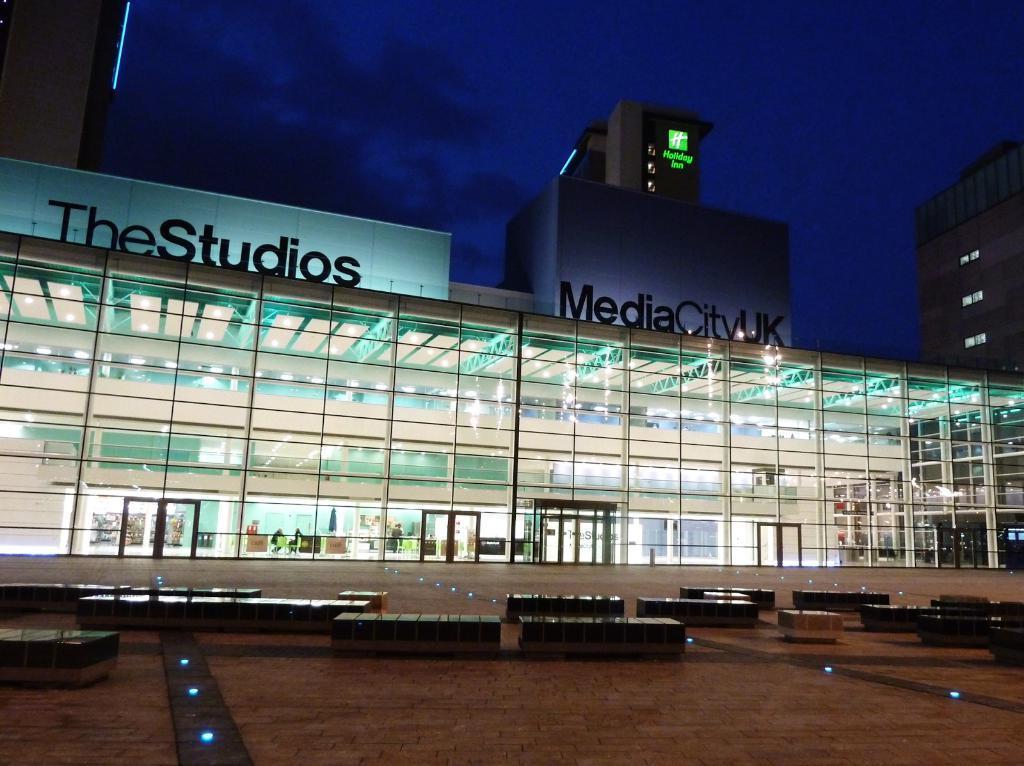Please provide a concise description of this image. In this image I can see two glass buildings and windows. I can see a blue color board and benches. The sky is in blue and black color. 